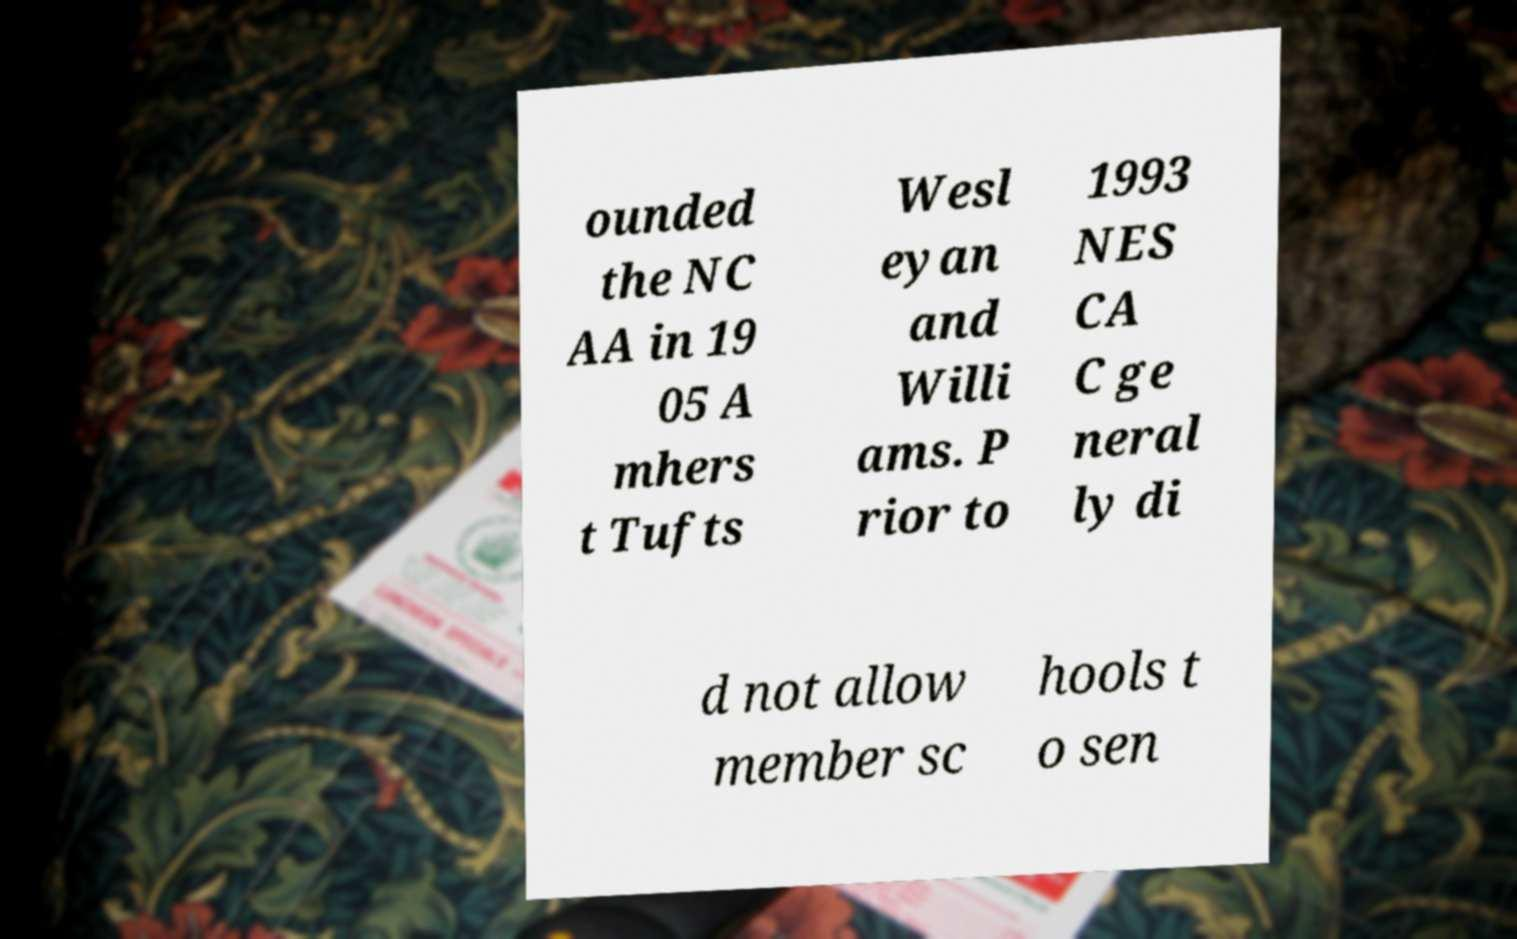Can you accurately transcribe the text from the provided image for me? ounded the NC AA in 19 05 A mhers t Tufts Wesl eyan and Willi ams. P rior to 1993 NES CA C ge neral ly di d not allow member sc hools t o sen 